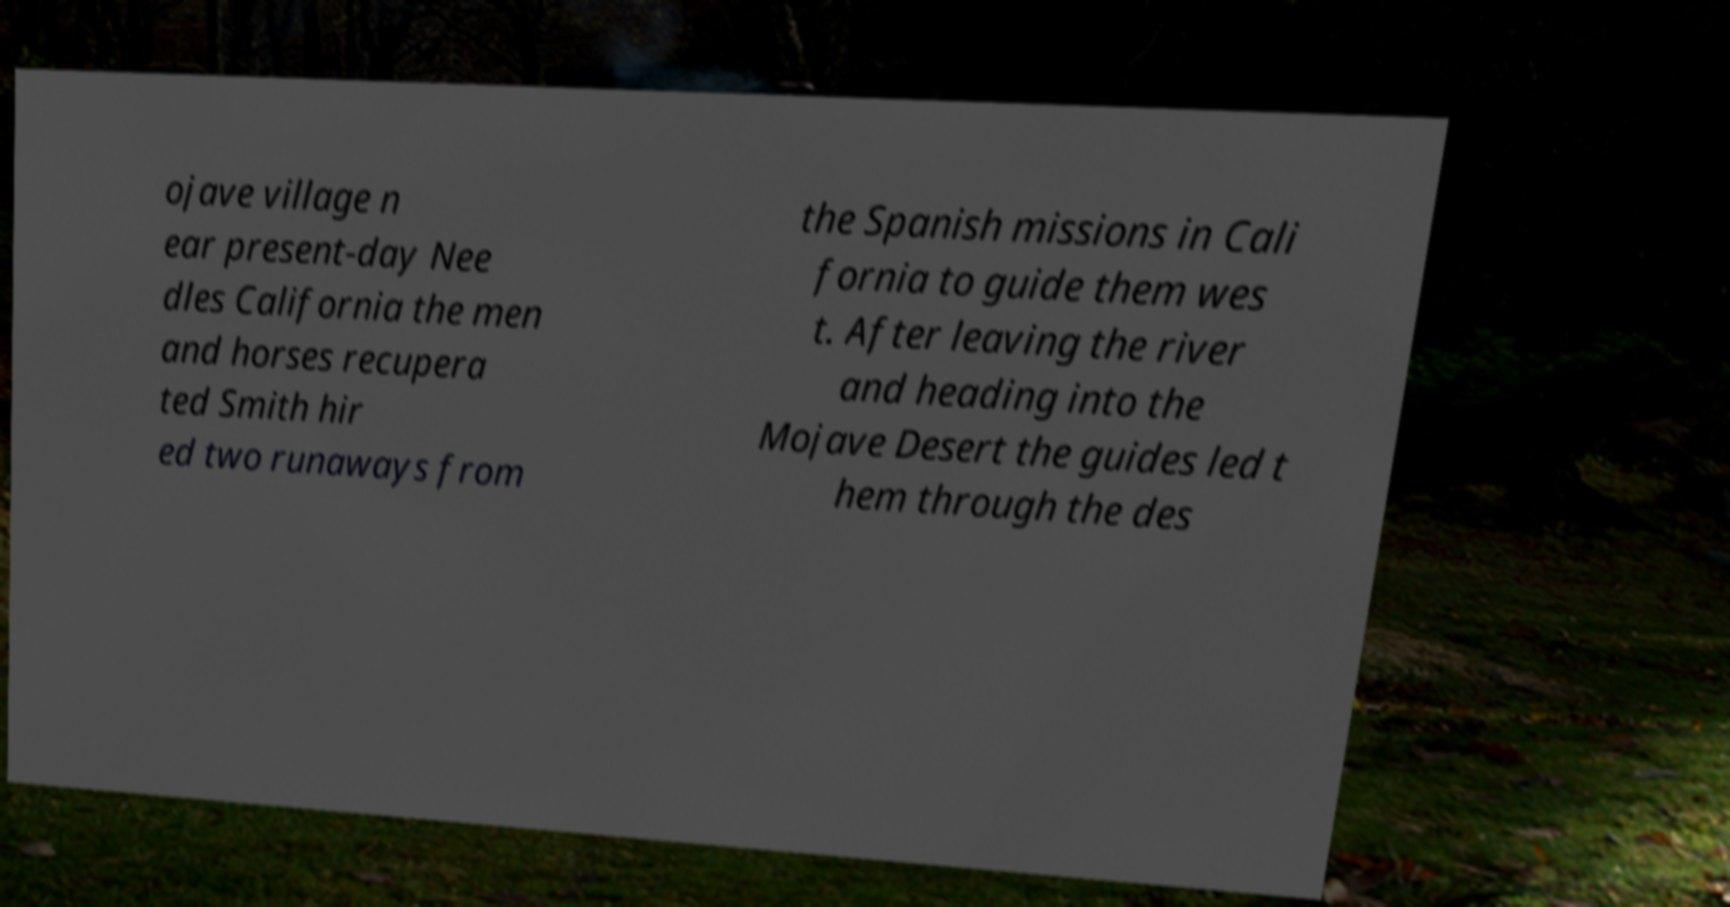Could you assist in decoding the text presented in this image and type it out clearly? ojave village n ear present-day Nee dles California the men and horses recupera ted Smith hir ed two runaways from the Spanish missions in Cali fornia to guide them wes t. After leaving the river and heading into the Mojave Desert the guides led t hem through the des 